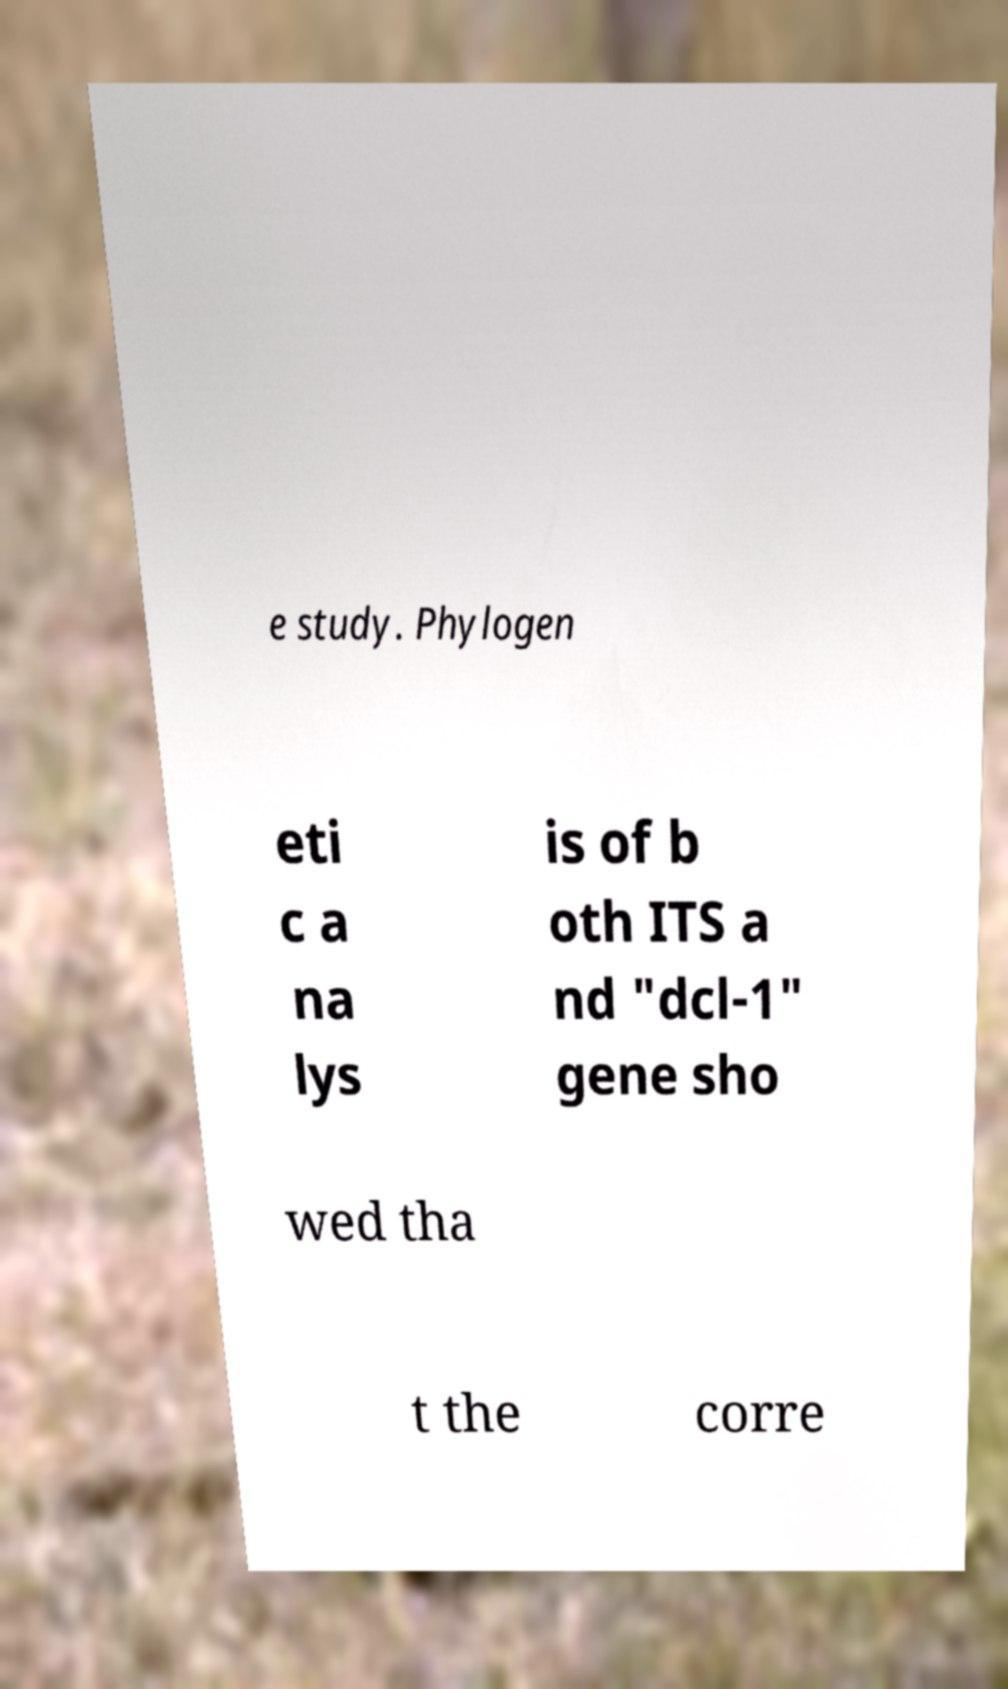Can you read and provide the text displayed in the image?This photo seems to have some interesting text. Can you extract and type it out for me? e study. Phylogen eti c a na lys is of b oth ITS a nd "dcl-1" gene sho wed tha t the corre 